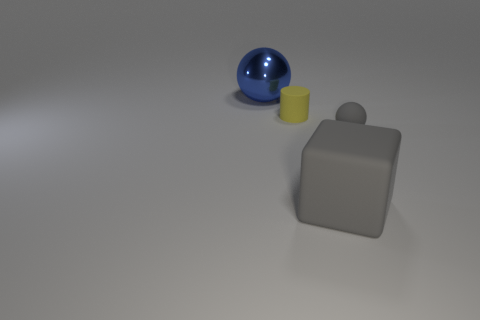Subtract all gray spheres. How many spheres are left? 1 Subtract all blocks. How many objects are left? 3 Subtract all rubber cubes. Subtract all gray rubber things. How many objects are left? 1 Add 1 big gray cubes. How many big gray cubes are left? 2 Add 4 large matte things. How many large matte things exist? 5 Add 4 shiny spheres. How many objects exist? 8 Subtract 0 cyan cylinders. How many objects are left? 4 Subtract all purple cylinders. Subtract all green spheres. How many cylinders are left? 1 Subtract all purple balls. How many cyan cylinders are left? 0 